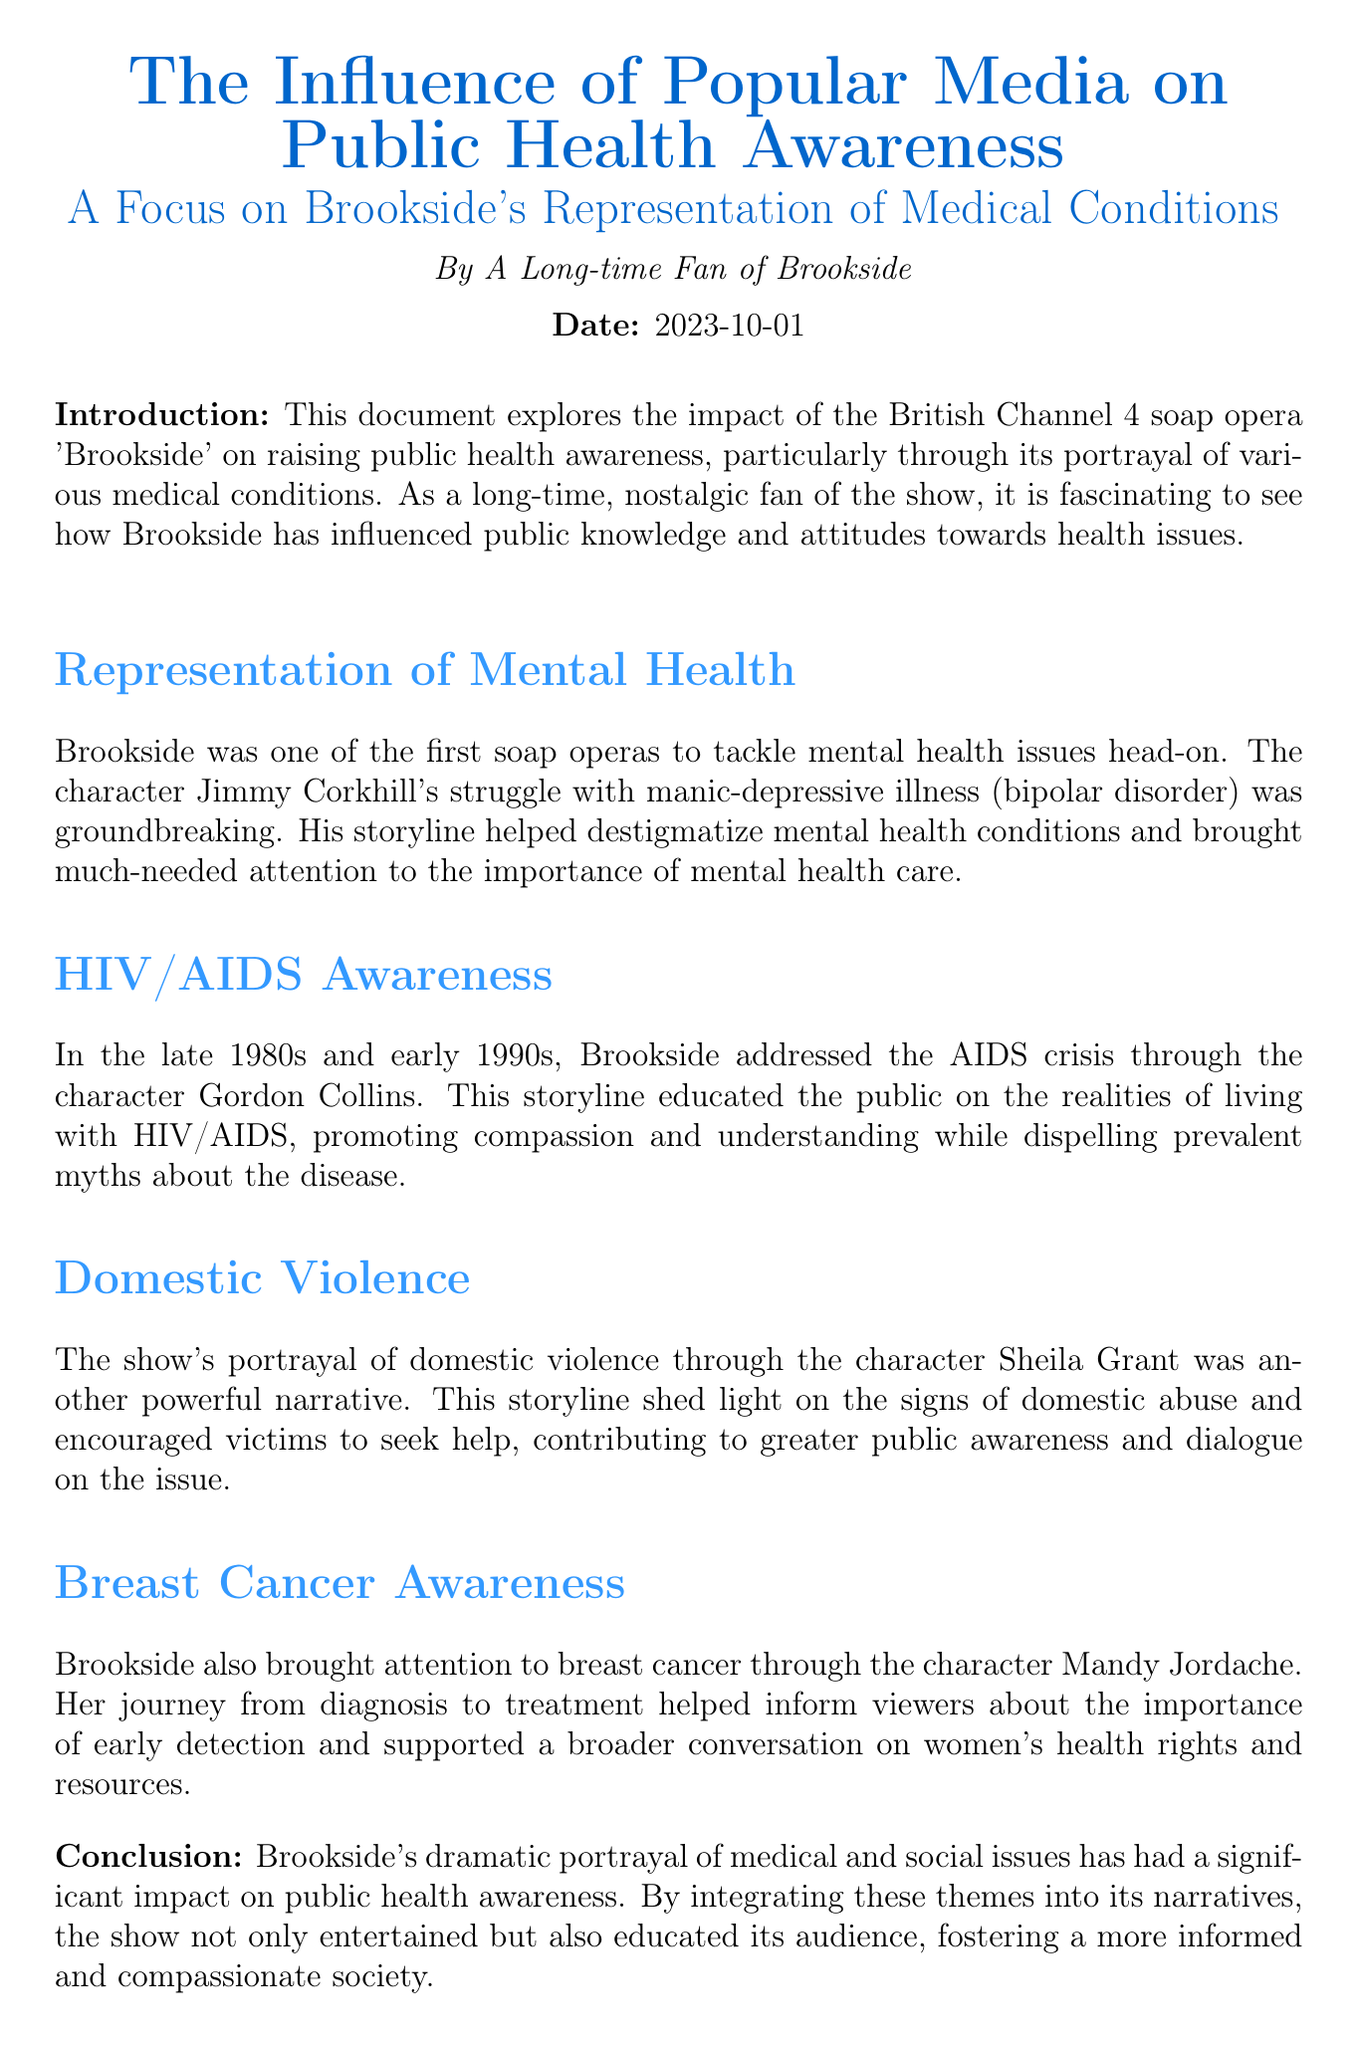What character struggled with bipolar disorder? The document specifically mentions the character Jimmy Corkhill, who portrayed the struggle with manic-depressive illness.
Answer: Jimmy Corkhill In which years did Brookside address the AIDS crisis? The document states that the AIDS crisis was addressed in the late 1980s and early 1990s.
Answer: late 1980s and early 1990s What issue did the character Sheila Grant represent? The document explains that Sheila Grant's storyline focused on domestic violence, raising awareness about the signs of abuse.
Answer: domestic violence Who helped inform viewers about breast cancer? The document identifies the character Mandy Jordache as instrumental in informing viewers about breast cancer.
Answer: Mandy Jordache What was the main focus of Brookside's influence on public health? The document outlines that Brookside's portrayal of medical conditions aimed at raising public health awareness.
Answer: raising public health awareness Which medical condition did Jimmy Corkhill represent? The document mentions that Jimmy Corkhill's storyline involved the medical condition of manic-depressive illness, also known as bipolar disorder.
Answer: bipolar disorder What did the character Gordon Collins educate the public about? According to the document, Gordon Collins' storyline was focused on the realities of living with HIV/AIDS.
Answer: HIV/AIDS What year is mentioned in the document? The document includes the date of publication as 2023-10-01.
Answer: 2023-10-01 